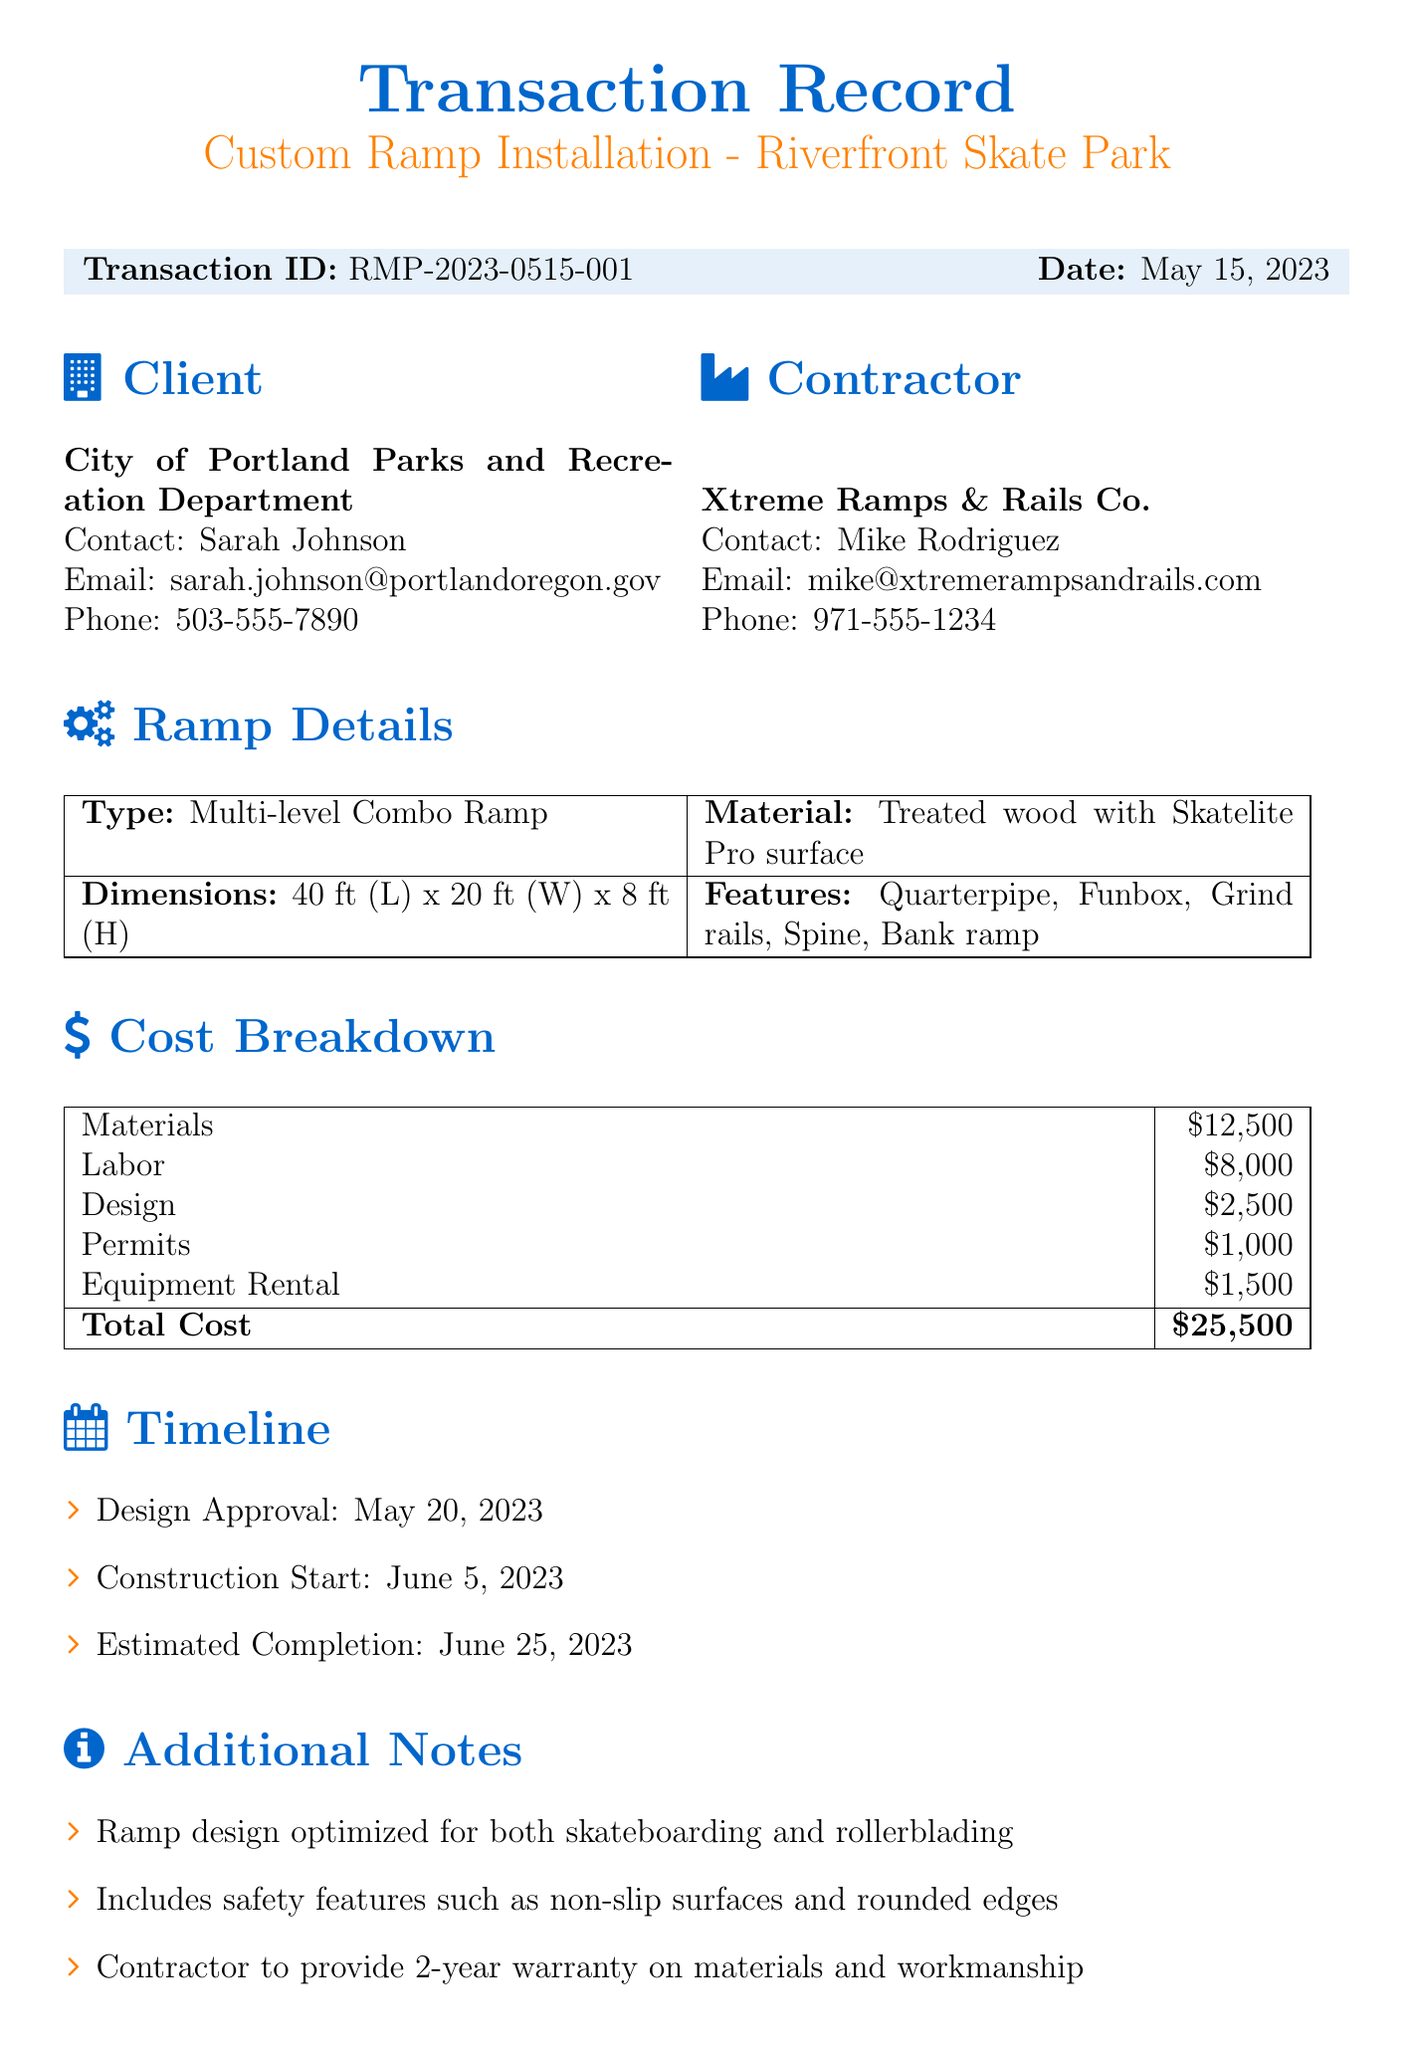What is the project name? The project name is listed in the document under transaction details.
Answer: Custom Ramp Installation - Riverfront Skate Park When is the estimated completion date? The estimated completion date is provided in the timeline section of the document.
Answer: June 25, 2023 What is the total cost of the ramp installation? The total cost can be found in the cost breakdown section of the document.
Answer: 25500 Who is the contact person for the client? The contact person from the City of Portland Parks and Recreation Department is mentioned in the client information section.
Answer: Sarah Johnson What percentage is due as a deposit upon contract signing? The payment terms section of the document specifies the deposit requirement.
Answer: 50% What types of features does the ramp include? The features of the ramp are listed in the ramp details section.
Answer: Quarterpipe, Funbox, Grind rails, Spine, Bank ramp Who is responsible for providing the warranty? The information about the warranty is found in the additional notes section.
Answer: Contractor When does construction start? The construction start date is specified in the timeline section.
Answer: June 5, 2023 What is the material used for the ramp? The material is detailed in the ramp details section of the document.
Answer: Treated wood with Skatelite Pro surface 